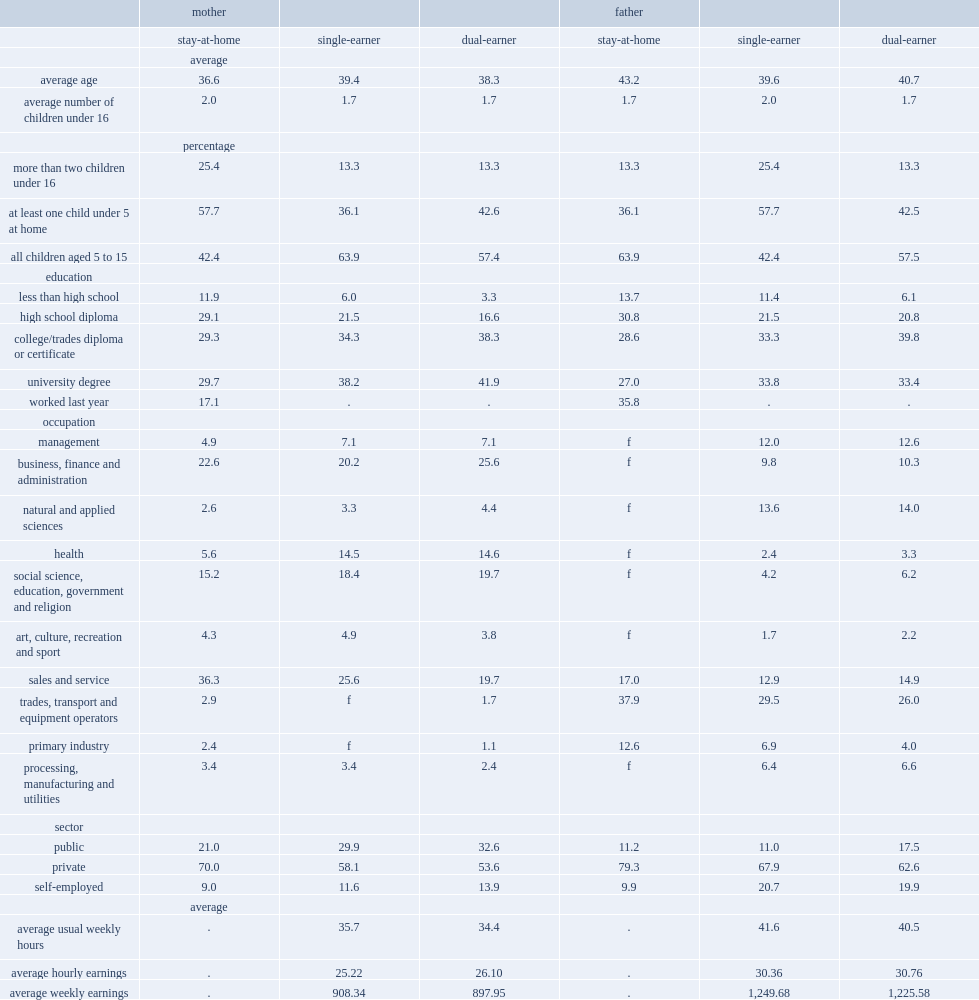Who were the youngest on average,stay-at-home mothers or single-earner mothers or mothers who were part of a dual-earner couple? Stay-at-home. What were the average ages of stay-at-home mothers and single-earner mothers and mothers who were in a dual-earning couple respectively? 36.6 39.4 38.3. Who were the most likely to have younger children,stay-at-home mothers or single-earner mothers or mothers who were part of a dual-earner couple? Stay-at-home. What was the percentage of stay-at-home mothers who had at least one child under the age of 5 at home? 57.7. What were the percentages of single-earner mothers and dual-earner mothers who had at least one child under the age of 5 at home respectively? 36.1 42.6. What was the multiple relationship between stay-at-home mothers and single-earner mothers,dual-earner mothers who had more than two children under 16. 1.909774. Who were the most likely to have lower levels of education(less than high school)? Stay-at-home. What was the percentage of stay-at-home mothers who had a high school diploma or less. 41. What were the percentages of single-earner mothers and dual-earner mothers who had a high school diploma or less respectively? 27.5 19.9. In 2014,what was the percentage of stay-at-home fathers who worked in 2013? 35.8. What was the percentage of stay-at-home mothers who were employed in sales and service occupations. 36.3. What were the percentages ofsingle-earner mothers and dual-earning mothers who were employed in sales and service occupations respectively? 25.6 19.7. Who were more likely to be working in health-related occupations and occupations in social science, education, government and religion,single-earner and dual-earner mothers or stay-at-home mothers ? Single-earner dual-earner. Who were the most likely to have lower levels of education(less than high school) of fathers? Stay-at-home. What was the percentage of stay-at-home fathers who had a high school diploma or less? 44.5. What were the percentages of single-earner fathers and dual-earner fathers who had a high school diploma or less respectively? 32.9 26.9. What were the percentages of stay-at-home fathers who were in trades, transport and equipment operator and related occupations, or in primary industry respectively? 50.5. What were the percentages of single-earner fathers and dual-earner fathers who were employed in management occupations, or in natural and applied sciences or in business, finance and administrative occupations respectively? 35.4 36.9. Who were more likely to be working in the public sector, dual-earner fathers or other fathers? Dual-earner. 